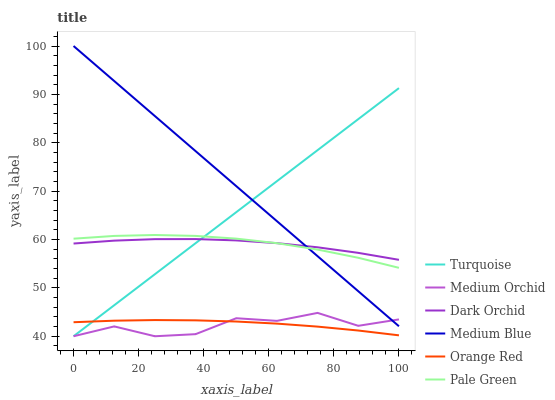Does Medium Orchid have the minimum area under the curve?
Answer yes or no. Yes. Does Medium Blue have the maximum area under the curve?
Answer yes or no. Yes. Does Medium Blue have the minimum area under the curve?
Answer yes or no. No. Does Medium Orchid have the maximum area under the curve?
Answer yes or no. No. Is Turquoise the smoothest?
Answer yes or no. Yes. Is Medium Orchid the roughest?
Answer yes or no. Yes. Is Medium Blue the smoothest?
Answer yes or no. No. Is Medium Blue the roughest?
Answer yes or no. No. Does Turquoise have the lowest value?
Answer yes or no. Yes. Does Medium Blue have the lowest value?
Answer yes or no. No. Does Medium Blue have the highest value?
Answer yes or no. Yes. Does Medium Orchid have the highest value?
Answer yes or no. No. Is Medium Orchid less than Dark Orchid?
Answer yes or no. Yes. Is Dark Orchid greater than Medium Orchid?
Answer yes or no. Yes. Does Turquoise intersect Dark Orchid?
Answer yes or no. Yes. Is Turquoise less than Dark Orchid?
Answer yes or no. No. Is Turquoise greater than Dark Orchid?
Answer yes or no. No. Does Medium Orchid intersect Dark Orchid?
Answer yes or no. No. 